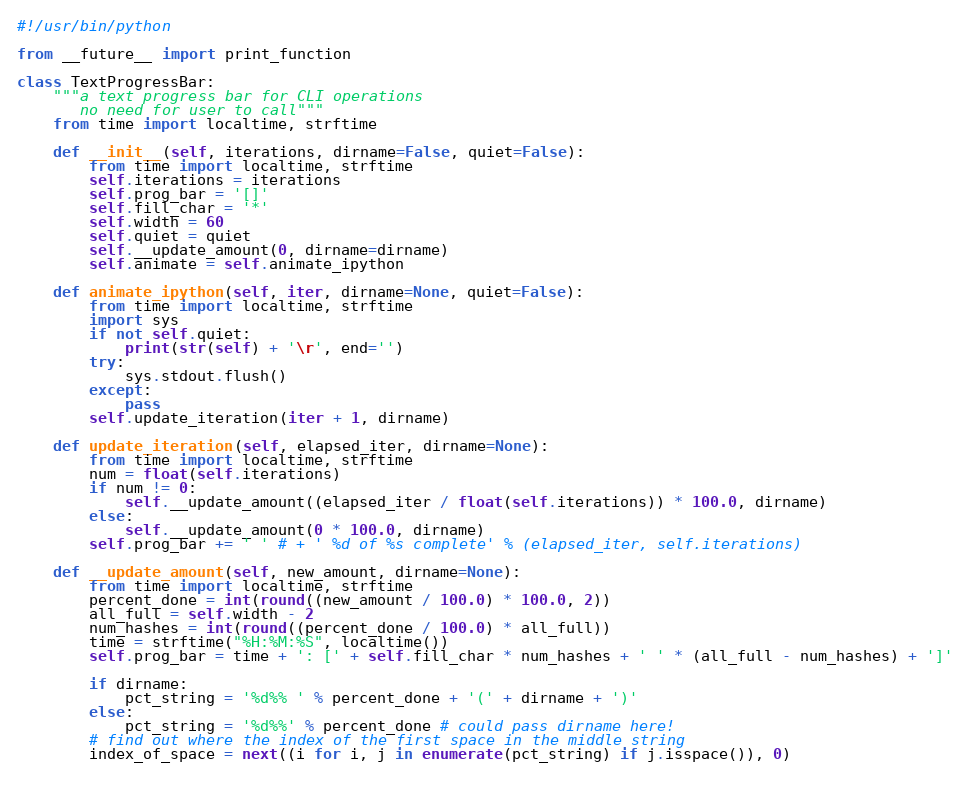<code> <loc_0><loc_0><loc_500><loc_500><_Python_>#!/usr/bin/python

from __future__ import print_function

class TextProgressBar:
    """a text progress bar for CLI operations
       no need for user to call"""
    from time import localtime, strftime
        
    def __init__(self, iterations, dirname=False, quiet=False):
        from time import localtime, strftime
        self.iterations = iterations
        self.prog_bar = '[]'
        self.fill_char = '*'
        self.width = 60
        self.quiet = quiet
        self.__update_amount(0, dirname=dirname)
        self.animate = self.animate_ipython

    def animate_ipython(self, iter, dirname=None, quiet=False):
        from time import localtime, strftime
        import sys
        if not self.quiet:
            print(str(self) + '\r', end='')
        try:
            sys.stdout.flush()
        except:
            pass
        self.update_iteration(iter + 1, dirname)

    def update_iteration(self, elapsed_iter, dirname=None):
        from time import localtime, strftime
        num = float(self.iterations)
        if num != 0:
            self.__update_amount((elapsed_iter / float(self.iterations)) * 100.0, dirname)
        else:
            self.__update_amount(0 * 100.0, dirname)
        self.prog_bar += ' ' # + ' %d of %s complete' % (elapsed_iter, self.iterations)

    def __update_amount(self, new_amount, dirname=None):
        from time import localtime, strftime
        percent_done = int(round((new_amount / 100.0) * 100.0, 2))
        all_full = self.width - 2
        num_hashes = int(round((percent_done / 100.0) * all_full))
        time = strftime("%H:%M:%S", localtime())
        self.prog_bar = time + ': [' + self.fill_char * num_hashes + ' ' * (all_full - num_hashes) + ']'
        
        if dirname:
            pct_string = '%d%% ' % percent_done + '(' + dirname + ')'
        else:
            pct_string = '%d%%' % percent_done # could pass dirname here!
        # find out where the index of the first space in the middle string
        index_of_space = next((i for i, j in enumerate(pct_string) if j.isspace()), 0)
        </code> 